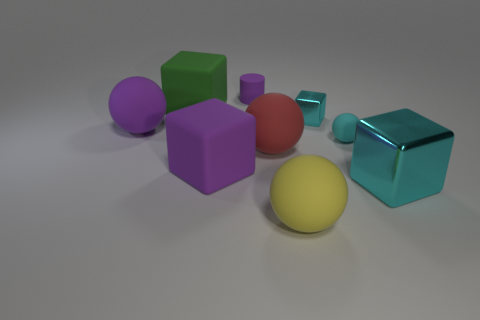Are there the same number of tiny purple matte cylinders to the right of the rubber cylinder and large green metallic cubes? After carefully observing the elements in the image, I can confirm that the count of tiny purple matte cylinders to the right of the rubber cylinder is indeed equal to the number of large green metallic cubes present. 